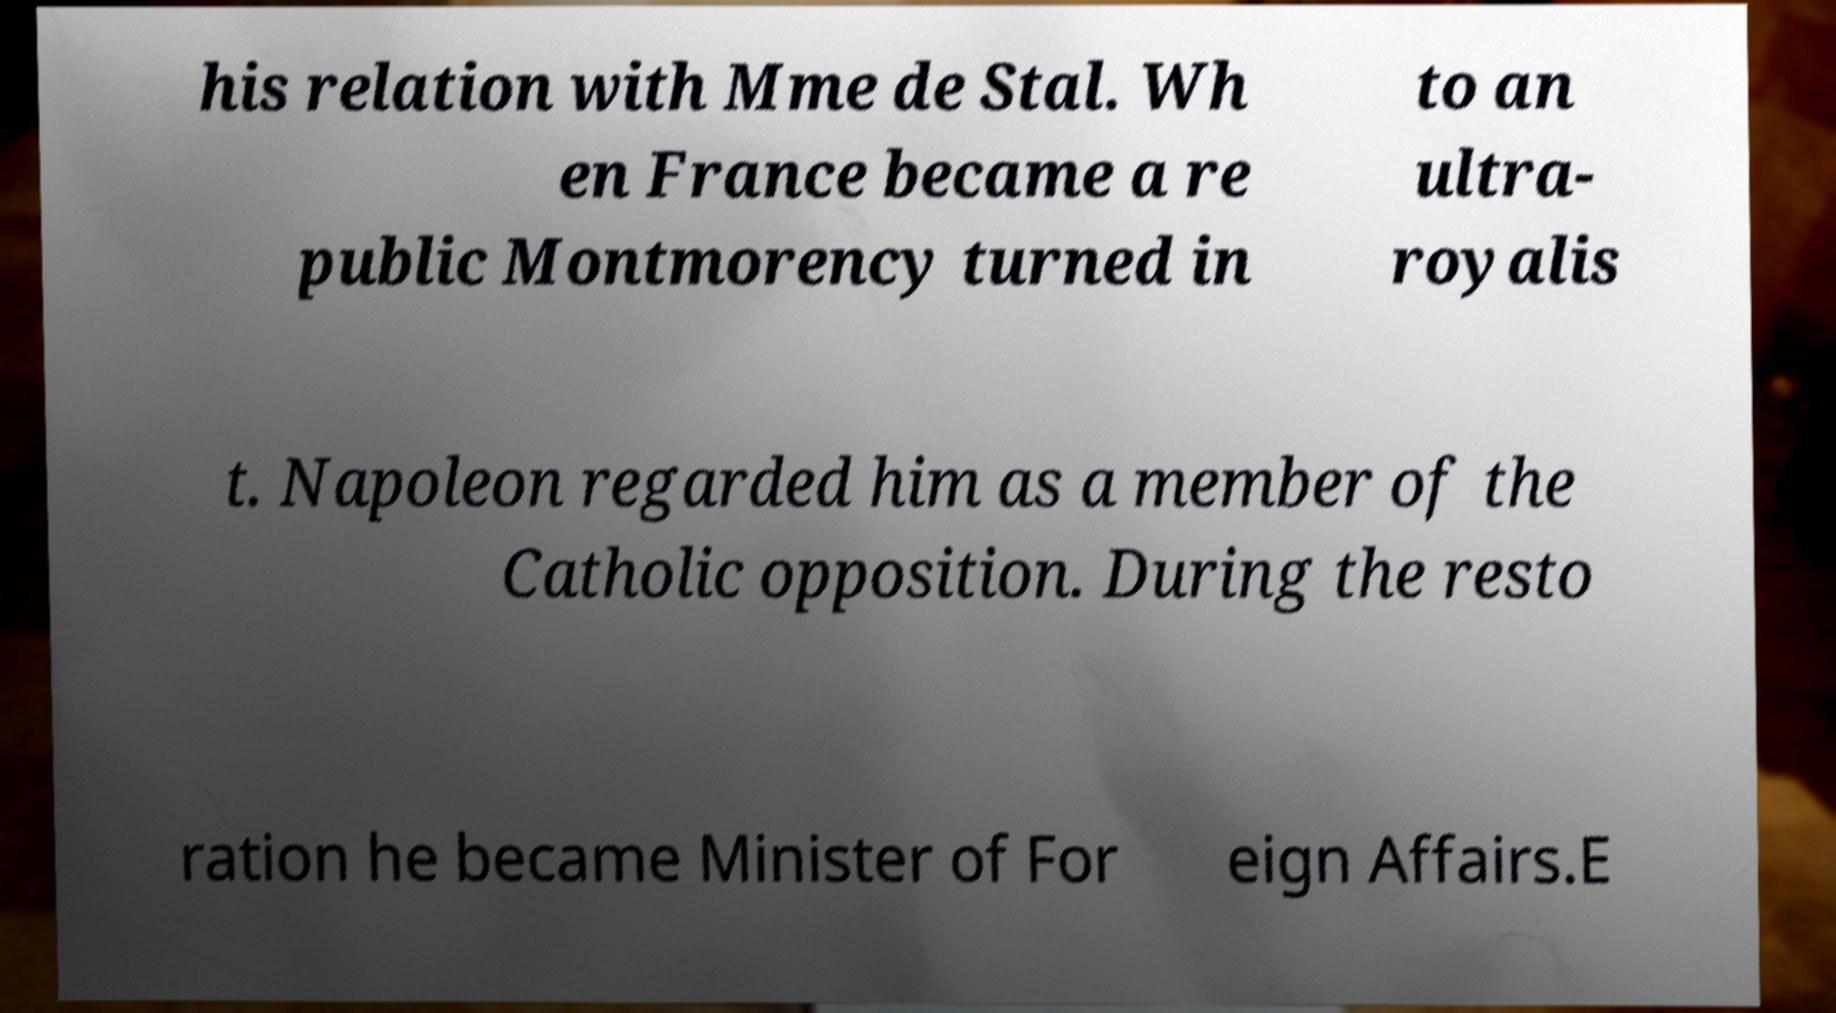There's text embedded in this image that I need extracted. Can you transcribe it verbatim? his relation with Mme de Stal. Wh en France became a re public Montmorency turned in to an ultra- royalis t. Napoleon regarded him as a member of the Catholic opposition. During the resto ration he became Minister of For eign Affairs.E 